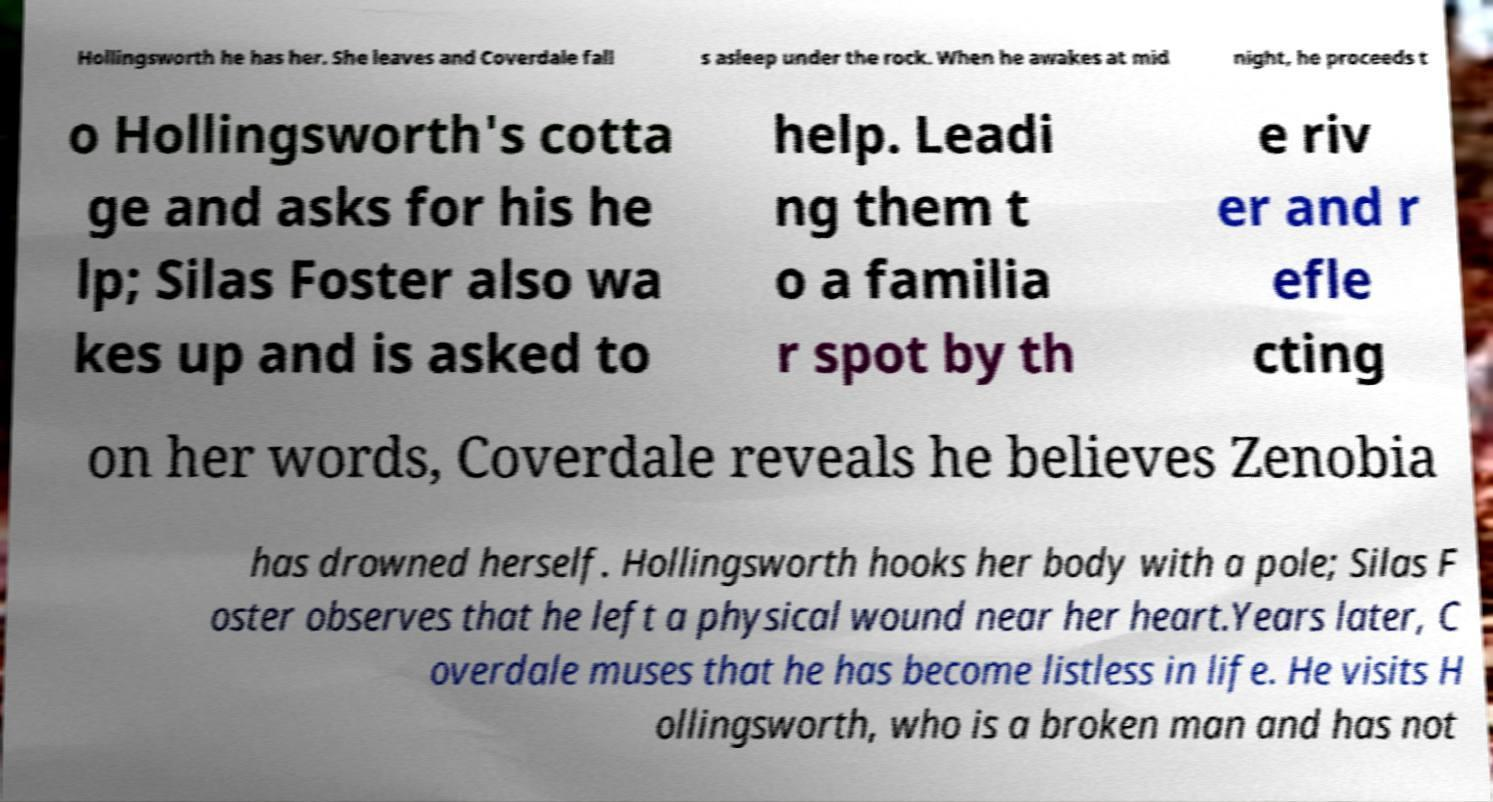Can you read and provide the text displayed in the image?This photo seems to have some interesting text. Can you extract and type it out for me? Hollingsworth he has her. She leaves and Coverdale fall s asleep under the rock. When he awakes at mid night, he proceeds t o Hollingsworth's cotta ge and asks for his he lp; Silas Foster also wa kes up and is asked to help. Leadi ng them t o a familia r spot by th e riv er and r efle cting on her words, Coverdale reveals he believes Zenobia has drowned herself. Hollingsworth hooks her body with a pole; Silas F oster observes that he left a physical wound near her heart.Years later, C overdale muses that he has become listless in life. He visits H ollingsworth, who is a broken man and has not 